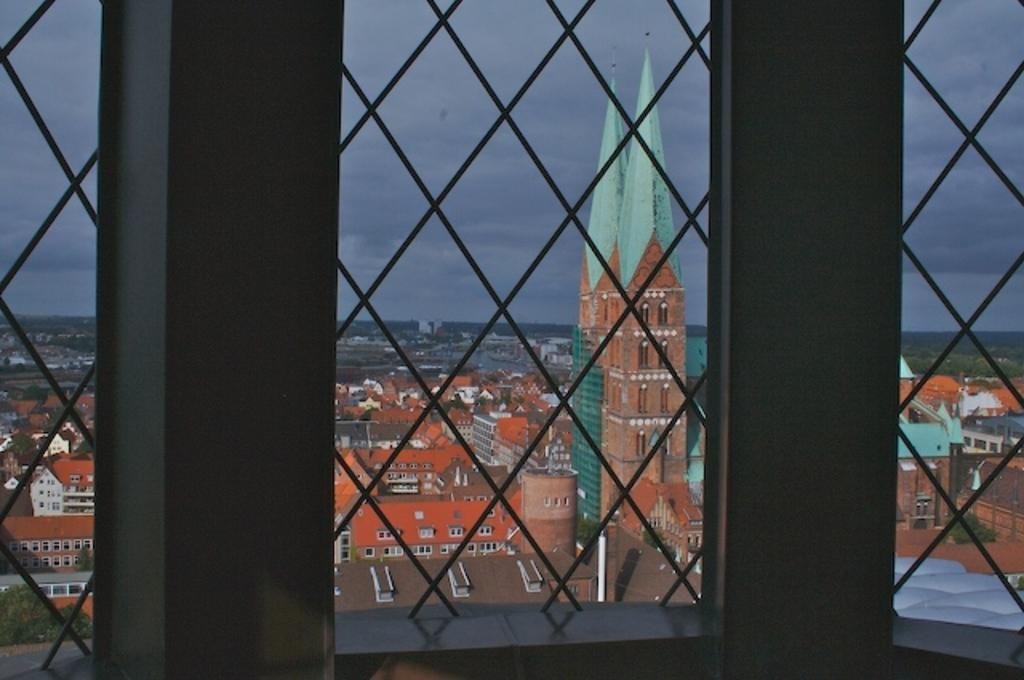What type of architectural feature is present in the image? There are windows with grills in the image. What can be seen through the windows? Buildings, trees, and the sky are visible through the windows. What type of soda is being served in the image? There is no soda present in the image; it features windows with grills and views of buildings, trees, and the sky. 